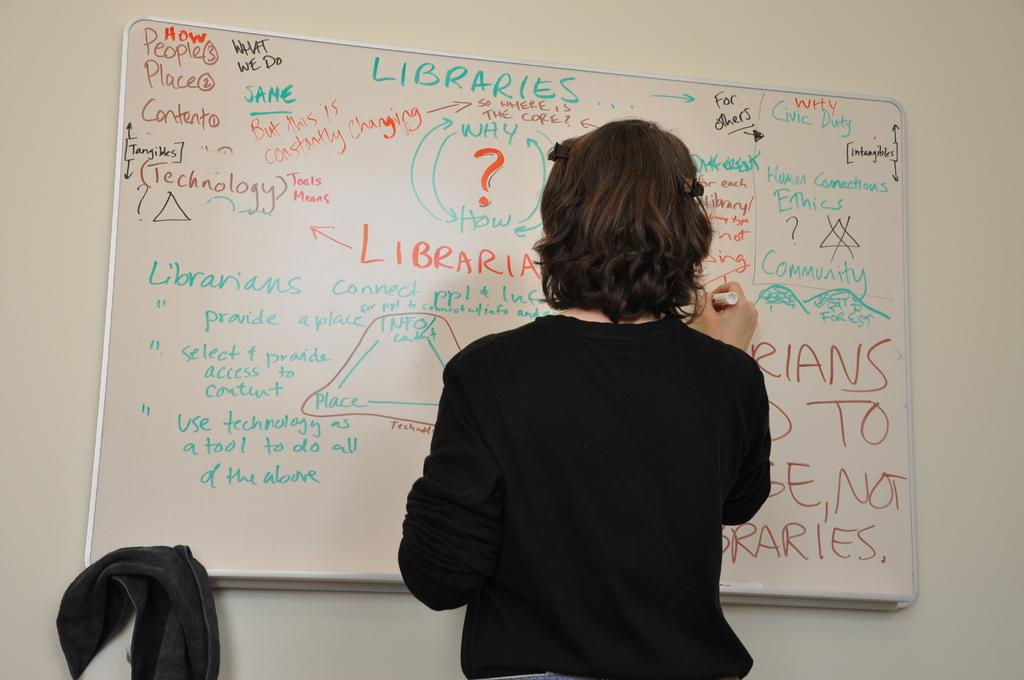<image>
Describe the image concisely. a woman writing on a white board with words Libraries on it 